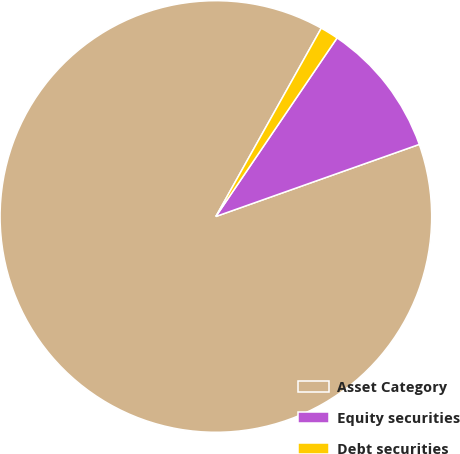Convert chart. <chart><loc_0><loc_0><loc_500><loc_500><pie_chart><fcel>Asset Category<fcel>Equity securities<fcel>Debt securities<nl><fcel>88.55%<fcel>10.09%<fcel>1.37%<nl></chart> 